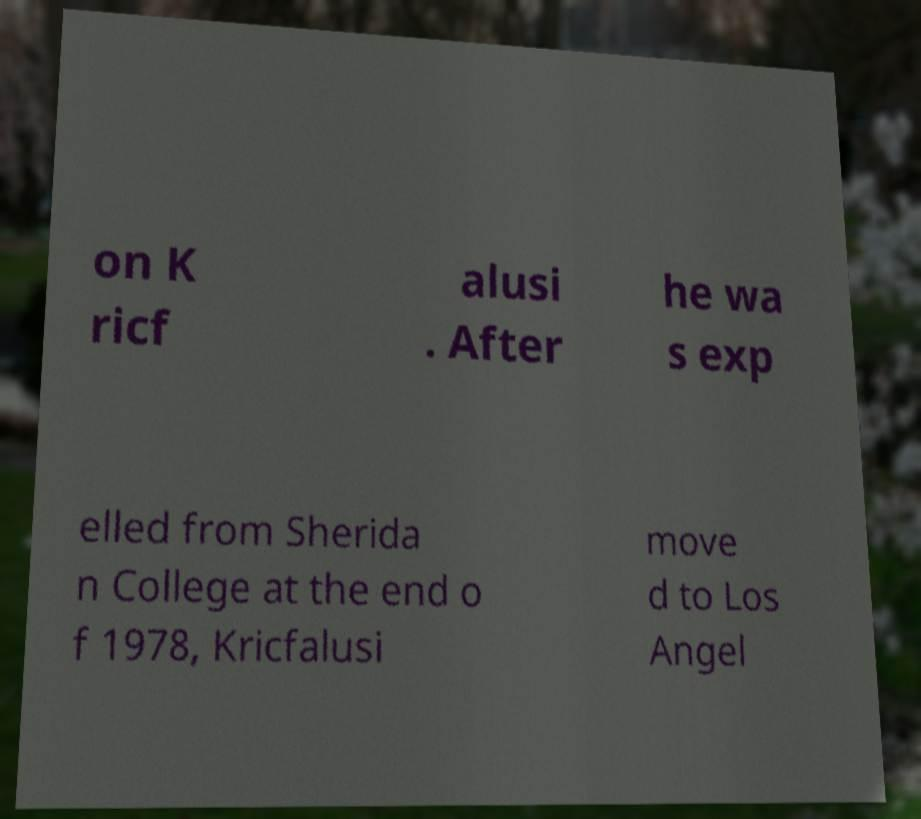There's text embedded in this image that I need extracted. Can you transcribe it verbatim? on K ricf alusi . After he wa s exp elled from Sherida n College at the end o f 1978, Kricfalusi move d to Los Angel 